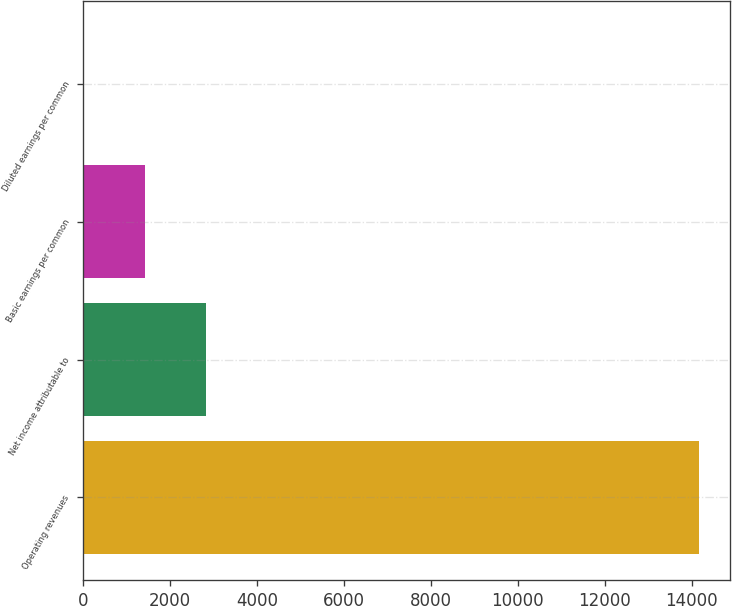Convert chart to OTSL. <chart><loc_0><loc_0><loc_500><loc_500><bar_chart><fcel>Operating revenues<fcel>Net income attributable to<fcel>Basic earnings per common<fcel>Diluted earnings per common<nl><fcel>14168<fcel>2835.84<fcel>1419.32<fcel>2.8<nl></chart> 